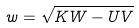<formula> <loc_0><loc_0><loc_500><loc_500>w = \sqrt { K W - U V }</formula> 